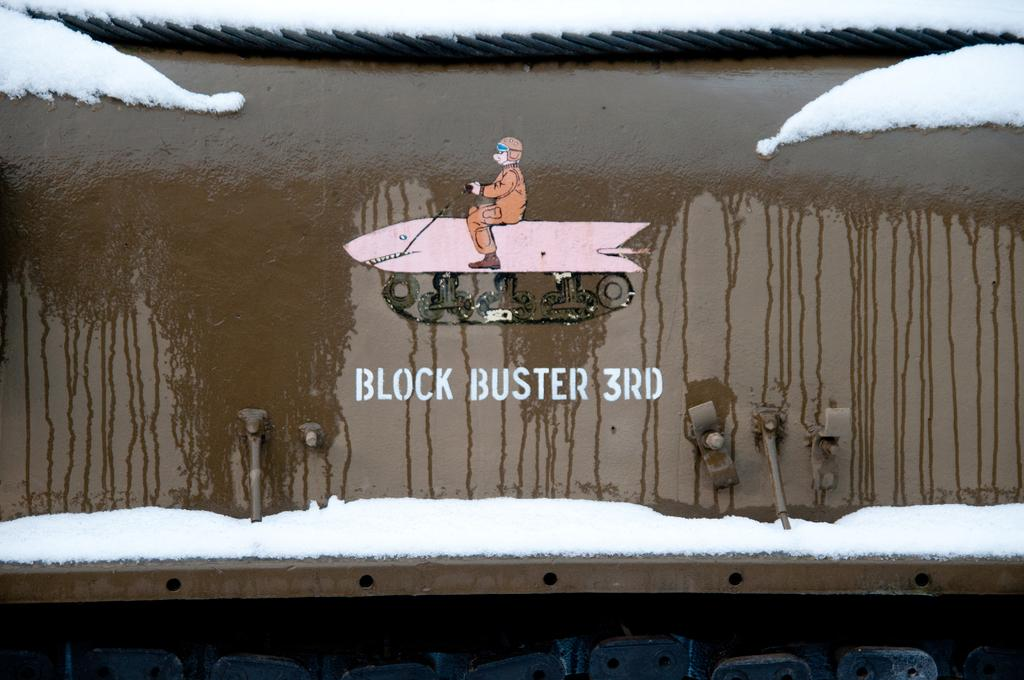<image>
Create a compact narrative representing the image presented. Man on a snowmobile on a wall, that has the text below it saying Block Buster 3rd 